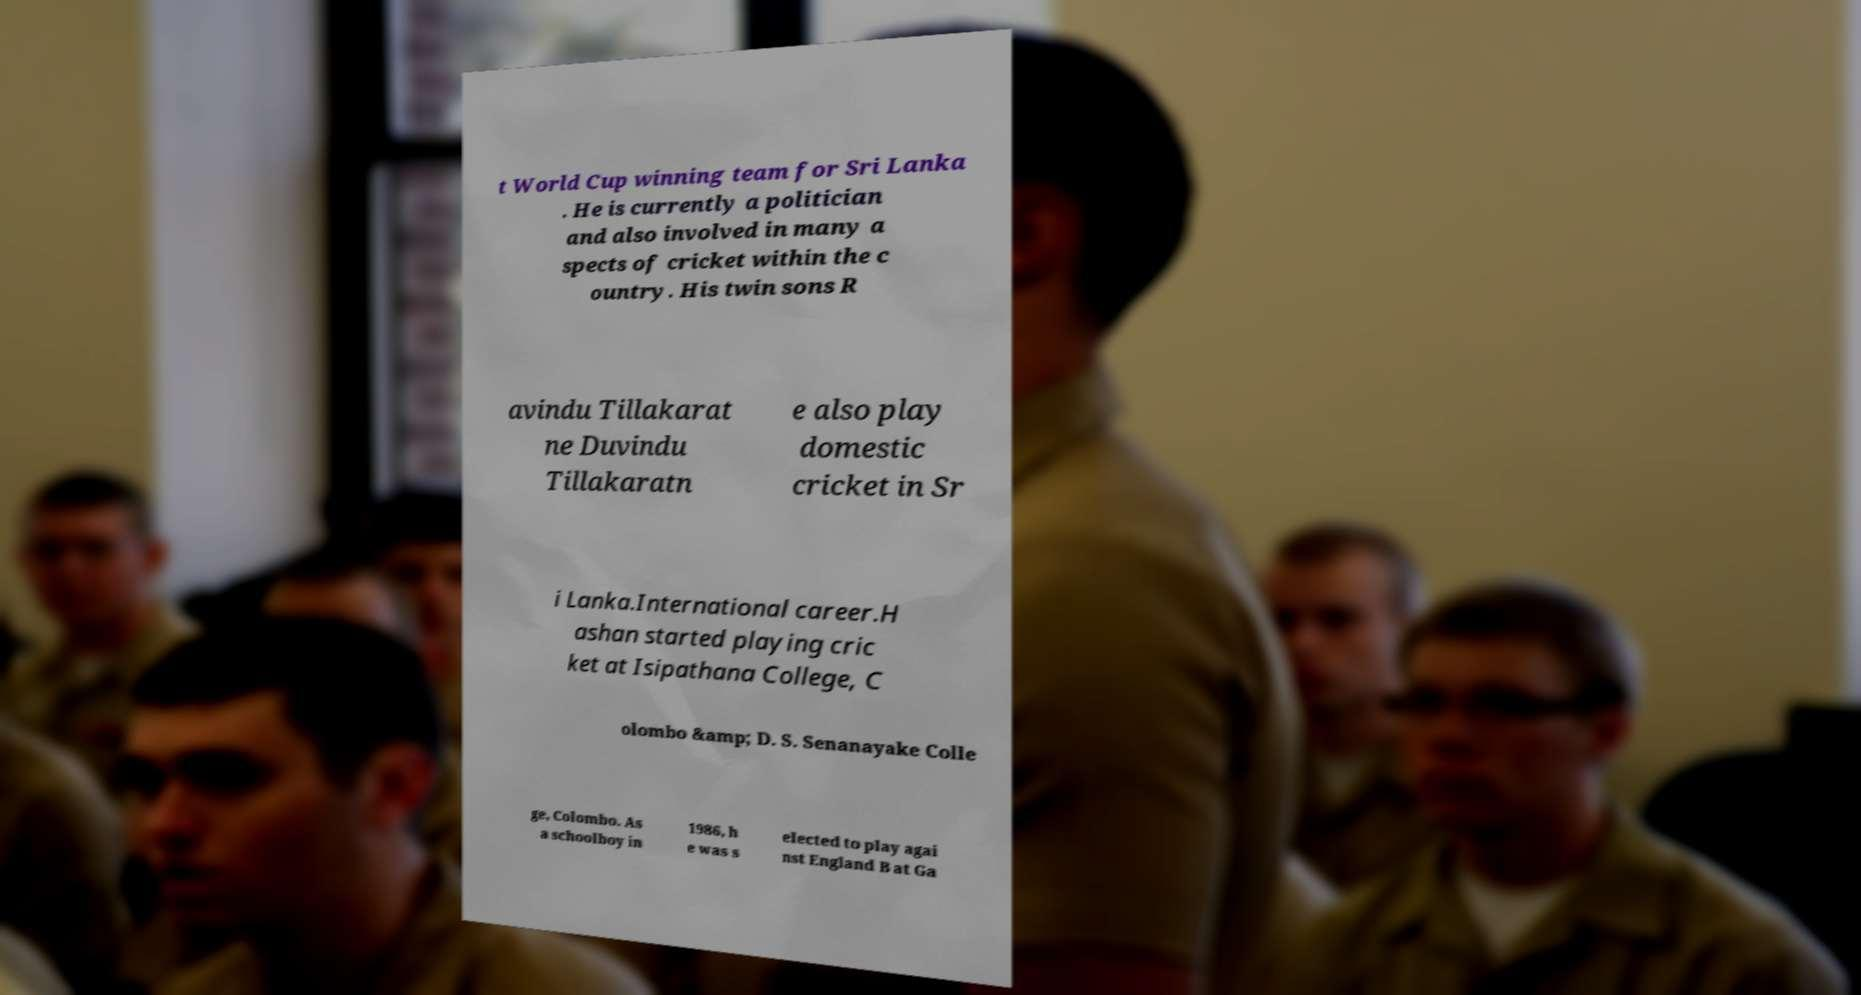I need the written content from this picture converted into text. Can you do that? t World Cup winning team for Sri Lanka . He is currently a politician and also involved in many a spects of cricket within the c ountry. His twin sons R avindu Tillakarat ne Duvindu Tillakaratn e also play domestic cricket in Sr i Lanka.International career.H ashan started playing cric ket at Isipathana College, C olombo &amp; D. S. Senanayake Colle ge, Colombo. As a schoolboy in 1986, h e was s elected to play agai nst England B at Ga 